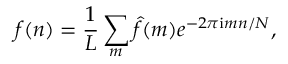Convert formula to latex. <formula><loc_0><loc_0><loc_500><loc_500>f ( n ) = \frac { 1 } { L } \sum _ { m } \hat { f } ( m ) e ^ { - 2 \pi i m n / N } ,</formula> 